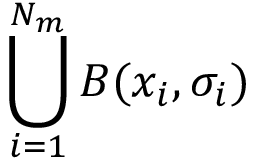<formula> <loc_0><loc_0><loc_500><loc_500>\bigcup _ { i = 1 } ^ { N _ { m } } B ( x _ { i } , \sigma _ { i } )</formula> 